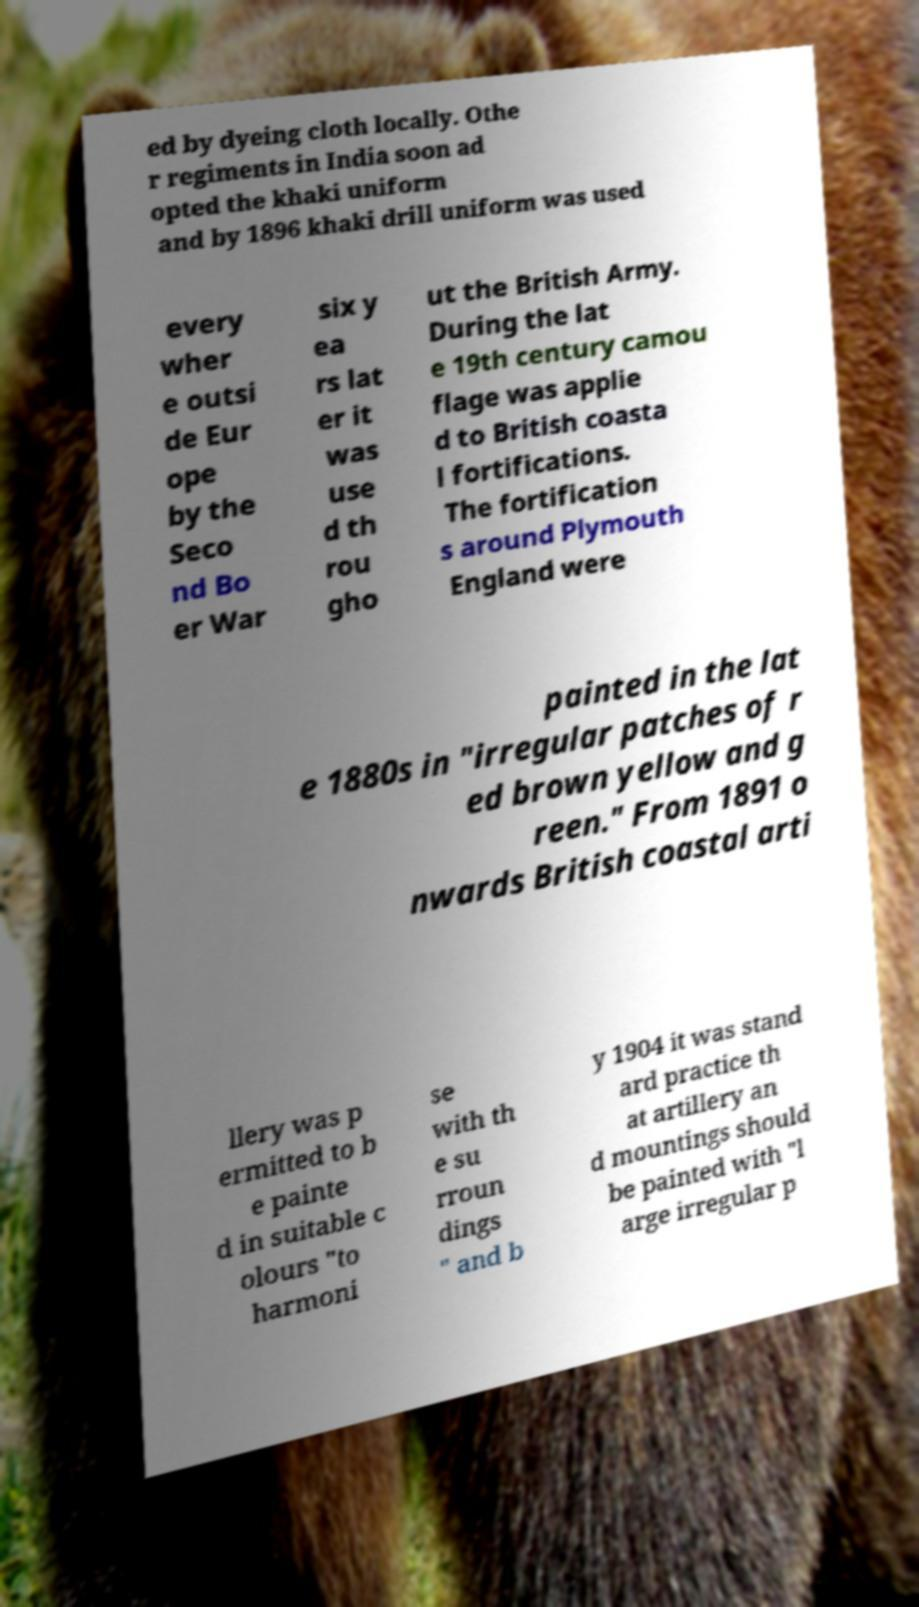Please read and relay the text visible in this image. What does it say? ed by dyeing cloth locally. Othe r regiments in India soon ad opted the khaki uniform and by 1896 khaki drill uniform was used every wher e outsi de Eur ope by the Seco nd Bo er War six y ea rs lat er it was use d th rou gho ut the British Army. During the lat e 19th century camou flage was applie d to British coasta l fortifications. The fortification s around Plymouth England were painted in the lat e 1880s in "irregular patches of r ed brown yellow and g reen." From 1891 o nwards British coastal arti llery was p ermitted to b e painte d in suitable c olours "to harmoni se with th e su rroun dings " and b y 1904 it was stand ard practice th at artillery an d mountings should be painted with "l arge irregular p 